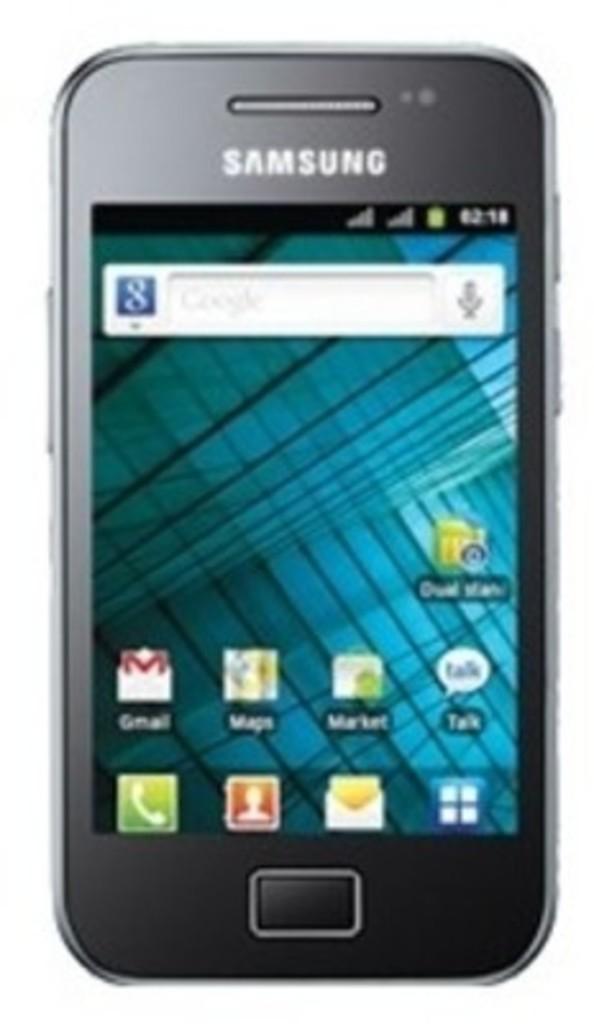What brand of phone is this?
Make the answer very short. Samsung. What does the app on the first row, left side of the screen say?
Ensure brevity in your answer.  Gmail. 